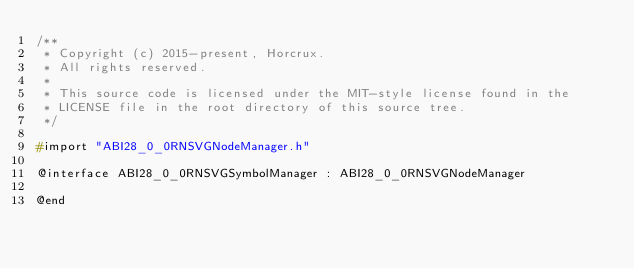Convert code to text. <code><loc_0><loc_0><loc_500><loc_500><_C_>/**
 * Copyright (c) 2015-present, Horcrux.
 * All rights reserved.
 *
 * This source code is licensed under the MIT-style license found in the
 * LICENSE file in the root directory of this source tree.
 */

#import "ABI28_0_0RNSVGNodeManager.h"

@interface ABI28_0_0RNSVGSymbolManager : ABI28_0_0RNSVGNodeManager

@end
</code> 